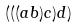Convert formula to latex. <formula><loc_0><loc_0><loc_500><loc_500>( ( ( a b ) c ) d )</formula> 